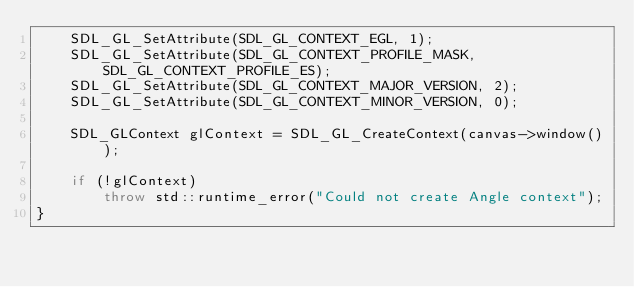<code> <loc_0><loc_0><loc_500><loc_500><_C++_>    SDL_GL_SetAttribute(SDL_GL_CONTEXT_EGL, 1);
    SDL_GL_SetAttribute(SDL_GL_CONTEXT_PROFILE_MASK, SDL_GL_CONTEXT_PROFILE_ES);
    SDL_GL_SetAttribute(SDL_GL_CONTEXT_MAJOR_VERSION, 2);
    SDL_GL_SetAttribute(SDL_GL_CONTEXT_MINOR_VERSION, 0);

    SDL_GLContext glContext = SDL_GL_CreateContext(canvas->window());

    if (!glContext)
        throw std::runtime_error("Could not create Angle context");
}
</code> 